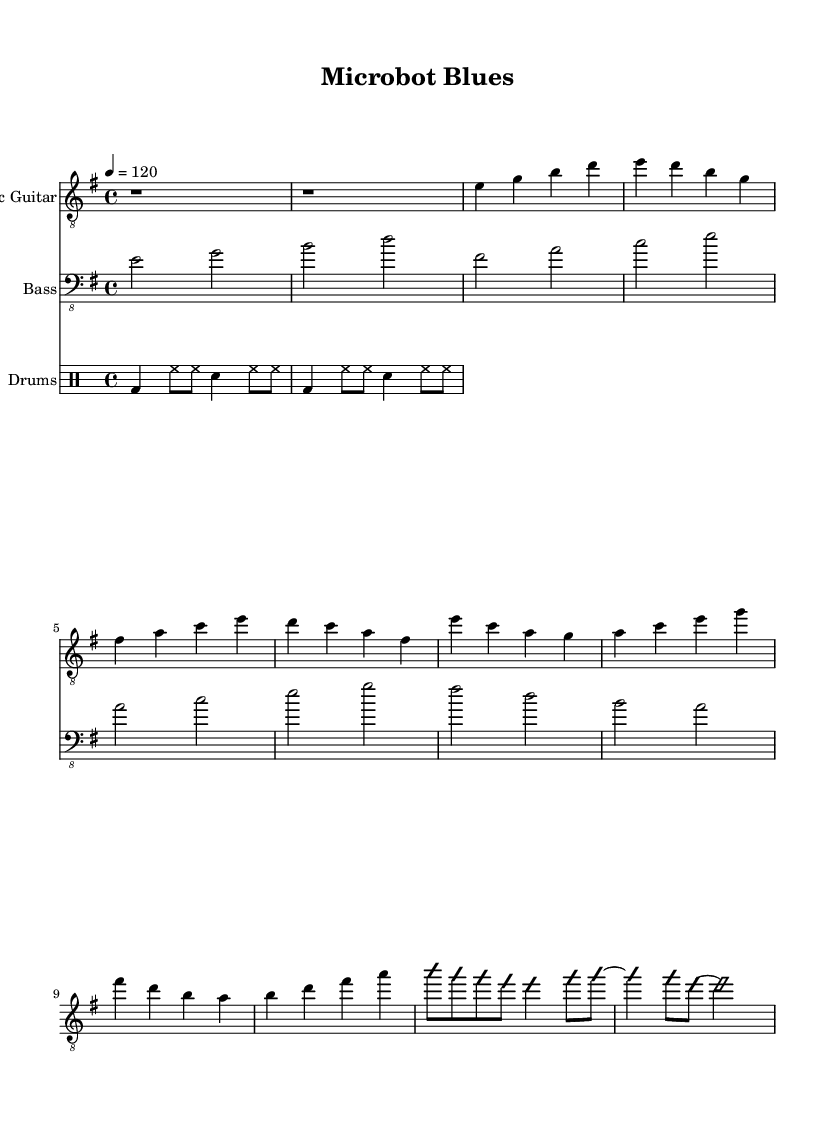What is the key signature of this music? The key signature indicated at the beginning of the score shows that there is 1 sharp, which corresponds to the key of E minor.
Answer: E minor What is the time signature of the piece? The time signature is found at the beginning of the score, represented as 4/4, indicating the piece has four beats per measure.
Answer: 4/4 What is the tempo marking for this music? The tempo is specified at the beginning with a notation indicating that the quarter note equals 120 beats per minute.
Answer: 120 How many measures are in the verse section of the music? By counting the measures indicated in the verse section (the first portion of the electric guitar part), there are four measures comprising the verse.
Answer: 4 What style of music does this sheet represent? The title "Microbot Blues" and the elements within the score, such as the electric guitar focus and lyrical themes suggestive of innovation and technology, reflect the genre of Electric Blues.
Answer: Electric Blues What types of instruments are featured in this score? The score lists an electric guitar, bass guitar, and drums, all of which are typical instruments featured in Electric Blues.
Answer: Electric guitar, bass, drums What improvisational element appears in the guitar part? The notation indicates that a section of the guitar part is an improvisation, signifying freedom and creativity in playing within that section.
Answer: Improvisation 